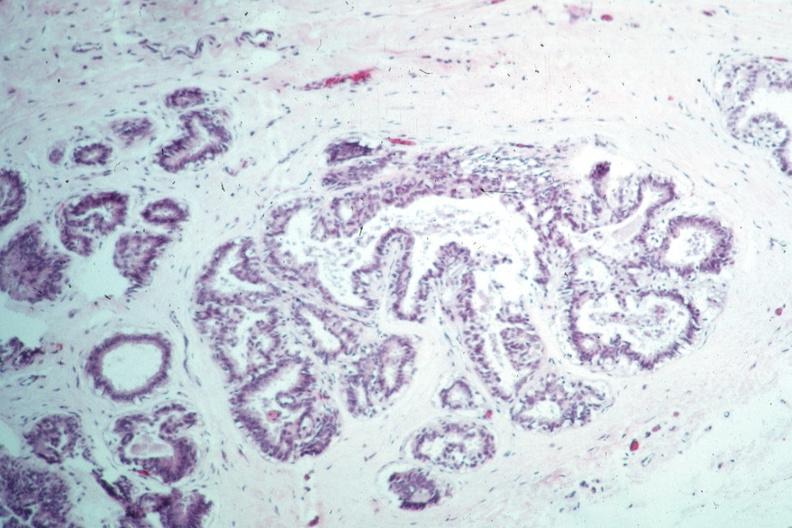what is present?
Answer the question using a single word or phrase. Breast 